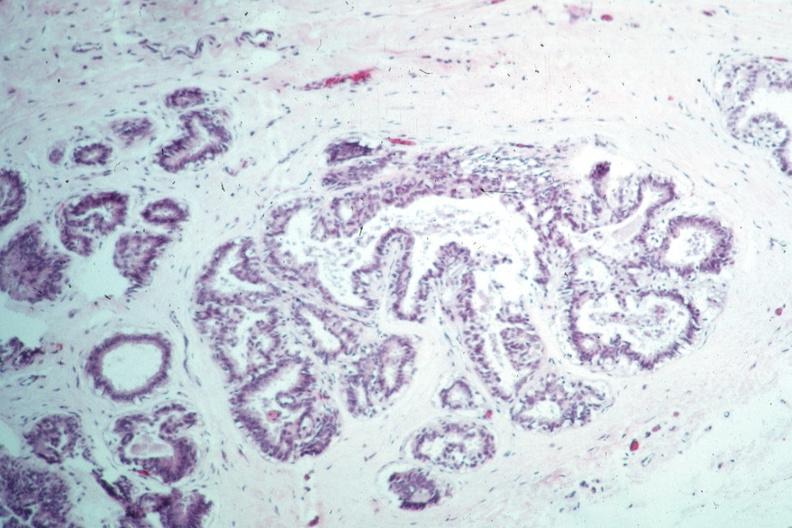what is present?
Answer the question using a single word or phrase. Breast 